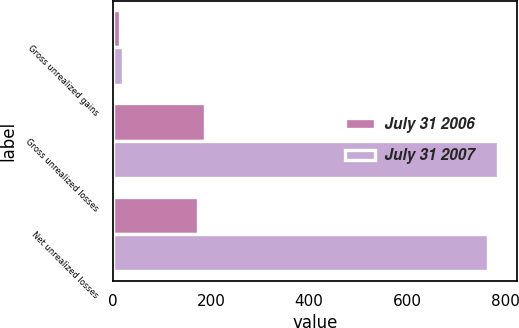<chart> <loc_0><loc_0><loc_500><loc_500><stacked_bar_chart><ecel><fcel>Gross unrealized gains<fcel>Gross unrealized losses<fcel>Net unrealized losses<nl><fcel>July 31 2006<fcel>15<fcel>188<fcel>173<nl><fcel>July 31 2007<fcel>20<fcel>785<fcel>765<nl></chart> 